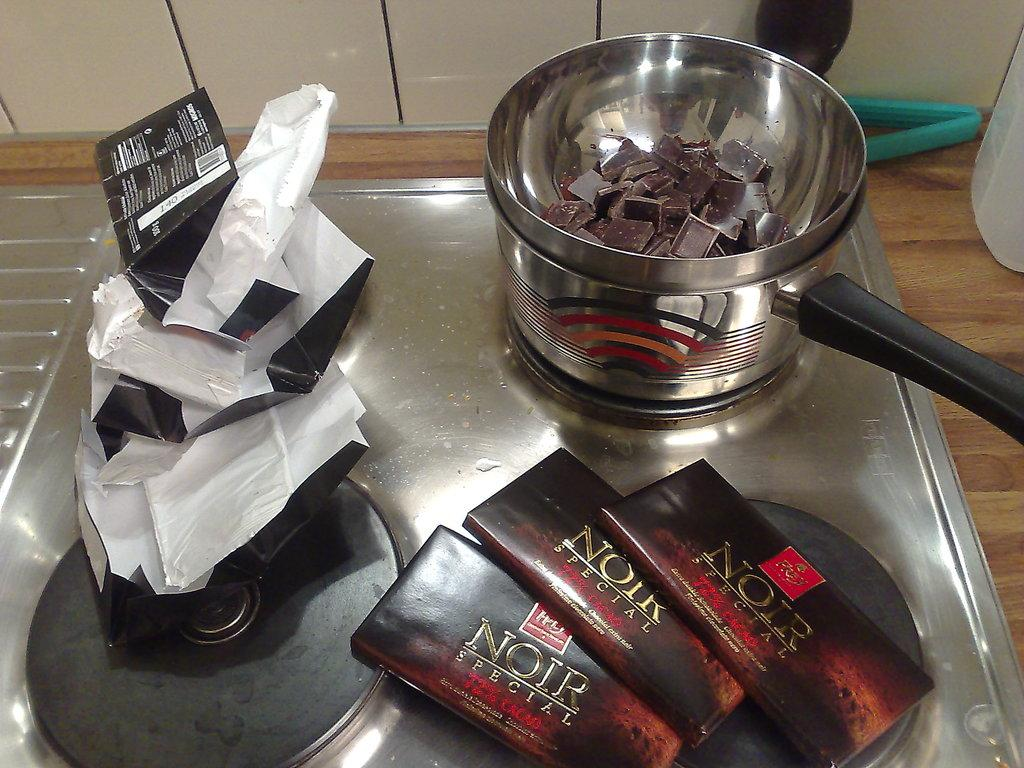<image>
Share a concise interpretation of the image provided. A few bars of Noir special chocolate is on a table with a pot. 